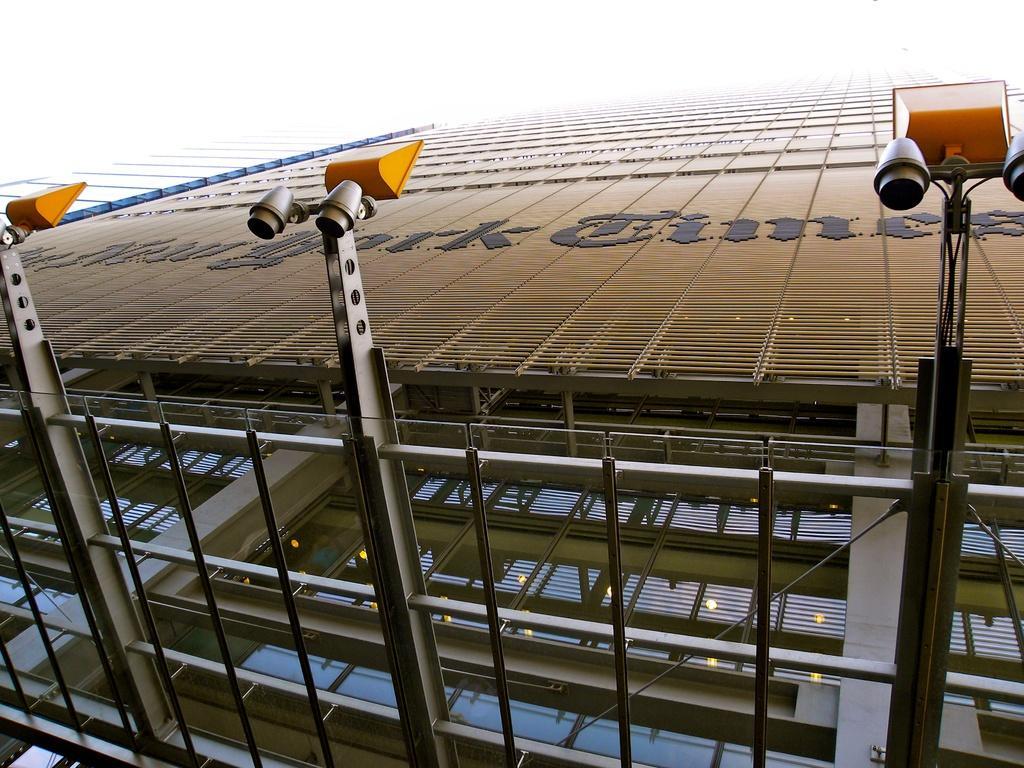Could you give a brief overview of what you see in this image? In this image we can see building and lights. In the background there is sky. 